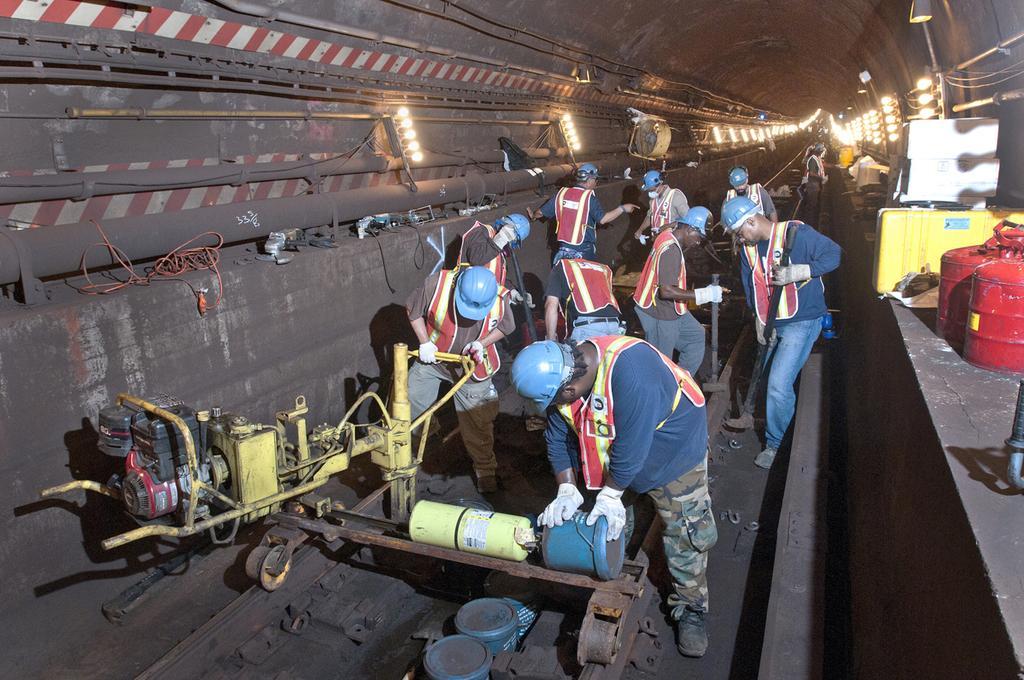Describe this image in one or two sentences. In this image I can see few railway tracks and few people in the centre. I can see these people are wearing gloves, helmets, shoes and jackets. On the both side of these railway tracks I can see number of lights and on the right side of this image I can see two red colour things, a yellow colour box and a white colour thing. I can also see number of wires on the both side of this image and in the front I can see a yellow colour thing. 